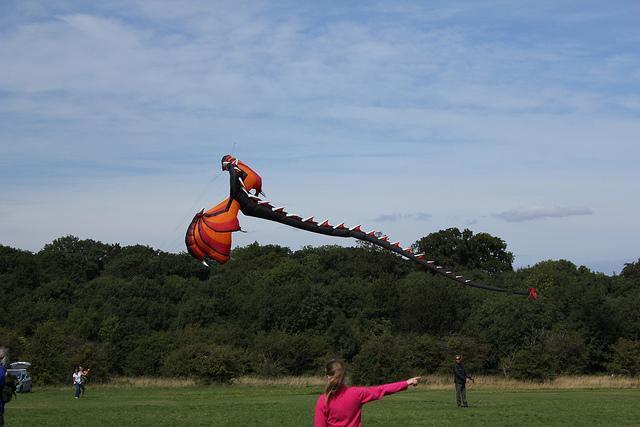How many glasses of orange juice are in the tray in the image?
Give a very brief answer. 0. 